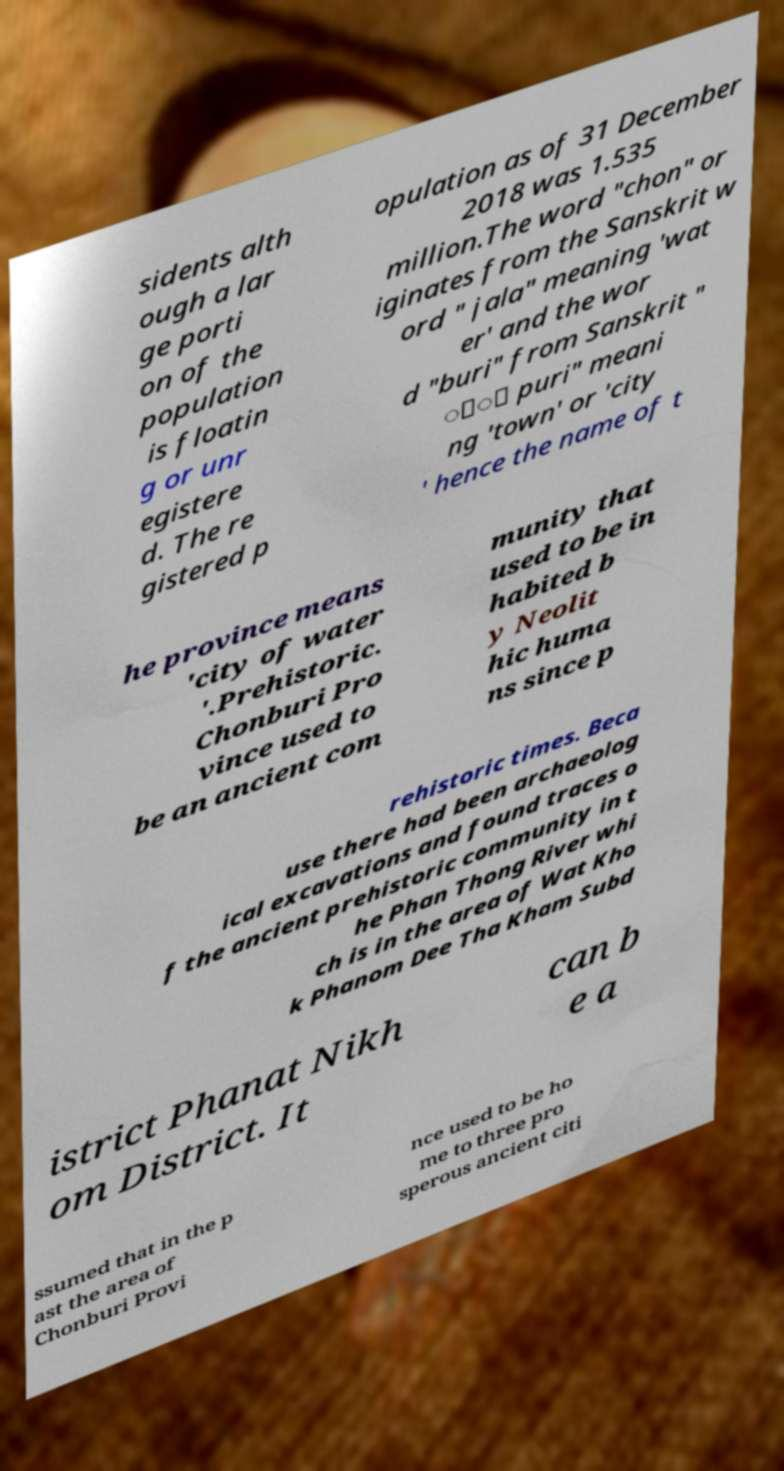Could you assist in decoding the text presented in this image and type it out clearly? sidents alth ough a lar ge porti on of the population is floatin g or unr egistere d. The re gistered p opulation as of 31 December 2018 was 1.535 million.The word "chon" or iginates from the Sanskrit w ord " jala" meaning 'wat er' and the wor d "buri" from Sanskrit " ुि puri" meani ng 'town' or 'city ' hence the name of t he province means 'city of water '.Prehistoric. Chonburi Pro vince used to be an ancient com munity that used to be in habited b y Neolit hic huma ns since p rehistoric times. Beca use there had been archaeolog ical excavations and found traces o f the ancient prehistoric community in t he Phan Thong River whi ch is in the area of Wat Kho k Phanom Dee Tha Kham Subd istrict Phanat Nikh om District. It can b e a ssumed that in the p ast the area of Chonburi Provi nce used to be ho me to three pro sperous ancient citi 